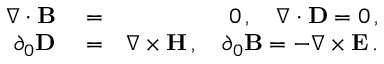<formula> <loc_0><loc_0><loc_500><loc_500>\begin{array} { r l r } { \nabla \cdot { B } } & = } & { 0 \, , \quad \nabla \cdot { D } = 0 \, , } \\ { \partial _ { 0 } { D } } & = } & { \nabla \times { H } \, , \quad \partial _ { 0 } { B } = - \nabla \times { E } \, . } \end{array}</formula> 